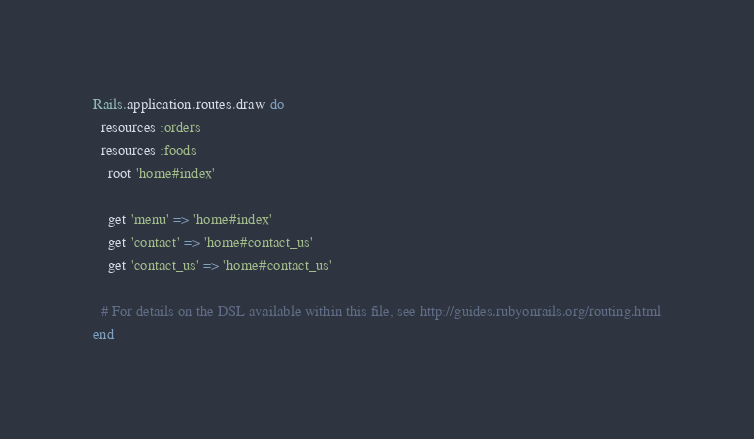Convert code to text. <code><loc_0><loc_0><loc_500><loc_500><_Ruby_>Rails.application.routes.draw do
  resources :orders
  resources :foods
	root 'home#index'

	get 'menu' => 'home#index'
	get 'contact' => 'home#contact_us'
	get 'contact_us' => 'home#contact_us'

  # For details on the DSL available within this file, see http://guides.rubyonrails.org/routing.html
end
</code> 